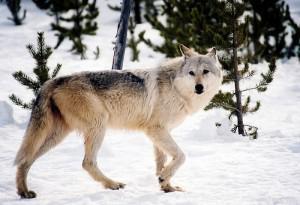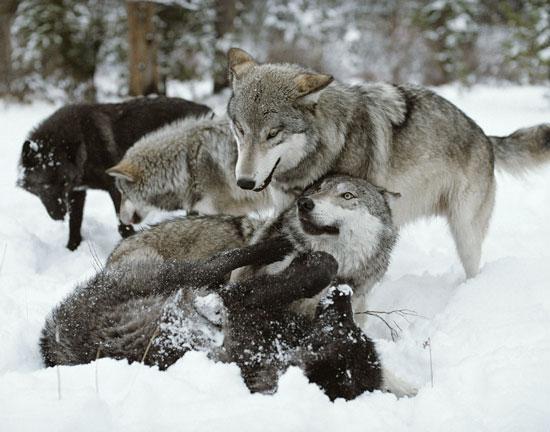The first image is the image on the left, the second image is the image on the right. Assess this claim about the two images: "There are two wolves". Correct or not? Answer yes or no. No. The first image is the image on the left, the second image is the image on the right. Analyze the images presented: Is the assertion "The right image contains at least four wolves positioned close together in a snow-covered scene." valid? Answer yes or no. Yes. 